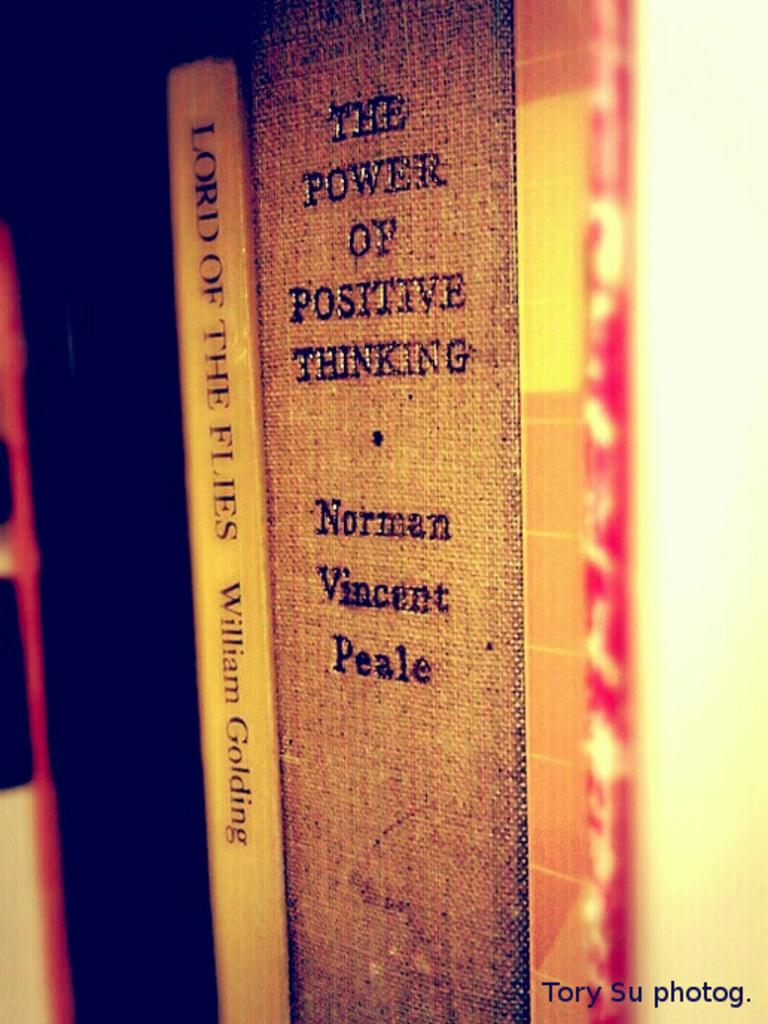<image>
Offer a succinct explanation of the picture presented. a picture with the spine of the power of positive thinking by norman vincent Peale. 